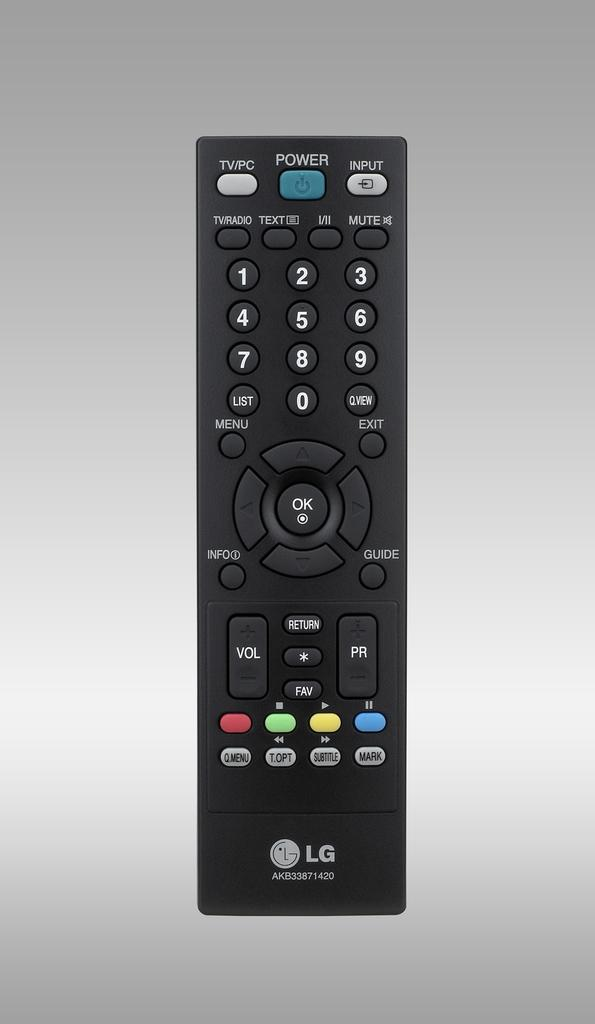<image>
Present a compact description of the photo's key features. an LG television remote with a blue power button at the top 